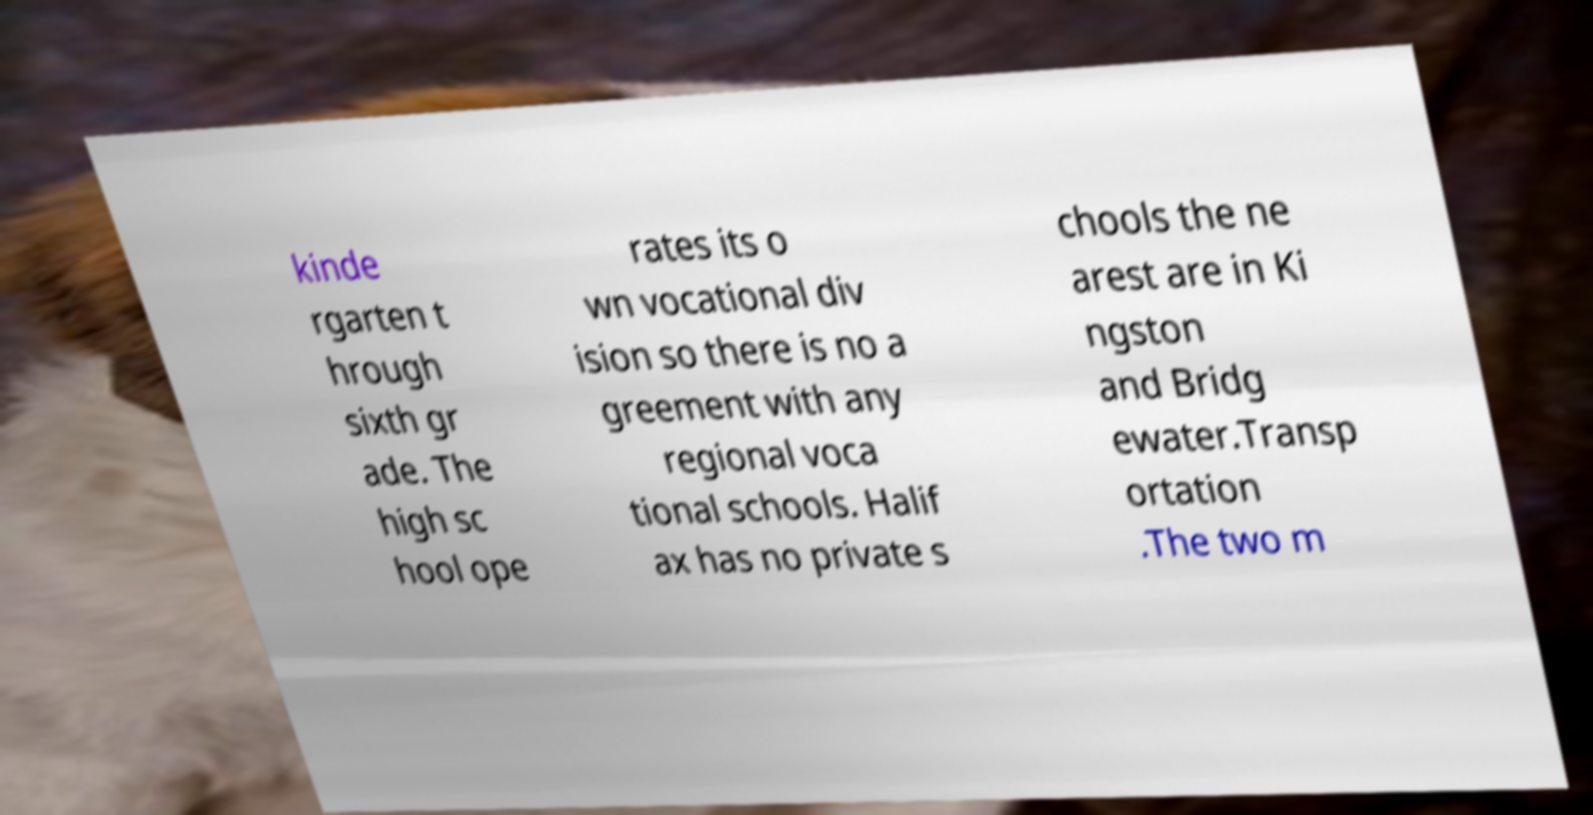Please identify and transcribe the text found in this image. kinde rgarten t hrough sixth gr ade. The high sc hool ope rates its o wn vocational div ision so there is no a greement with any regional voca tional schools. Halif ax has no private s chools the ne arest are in Ki ngston and Bridg ewater.Transp ortation .The two m 